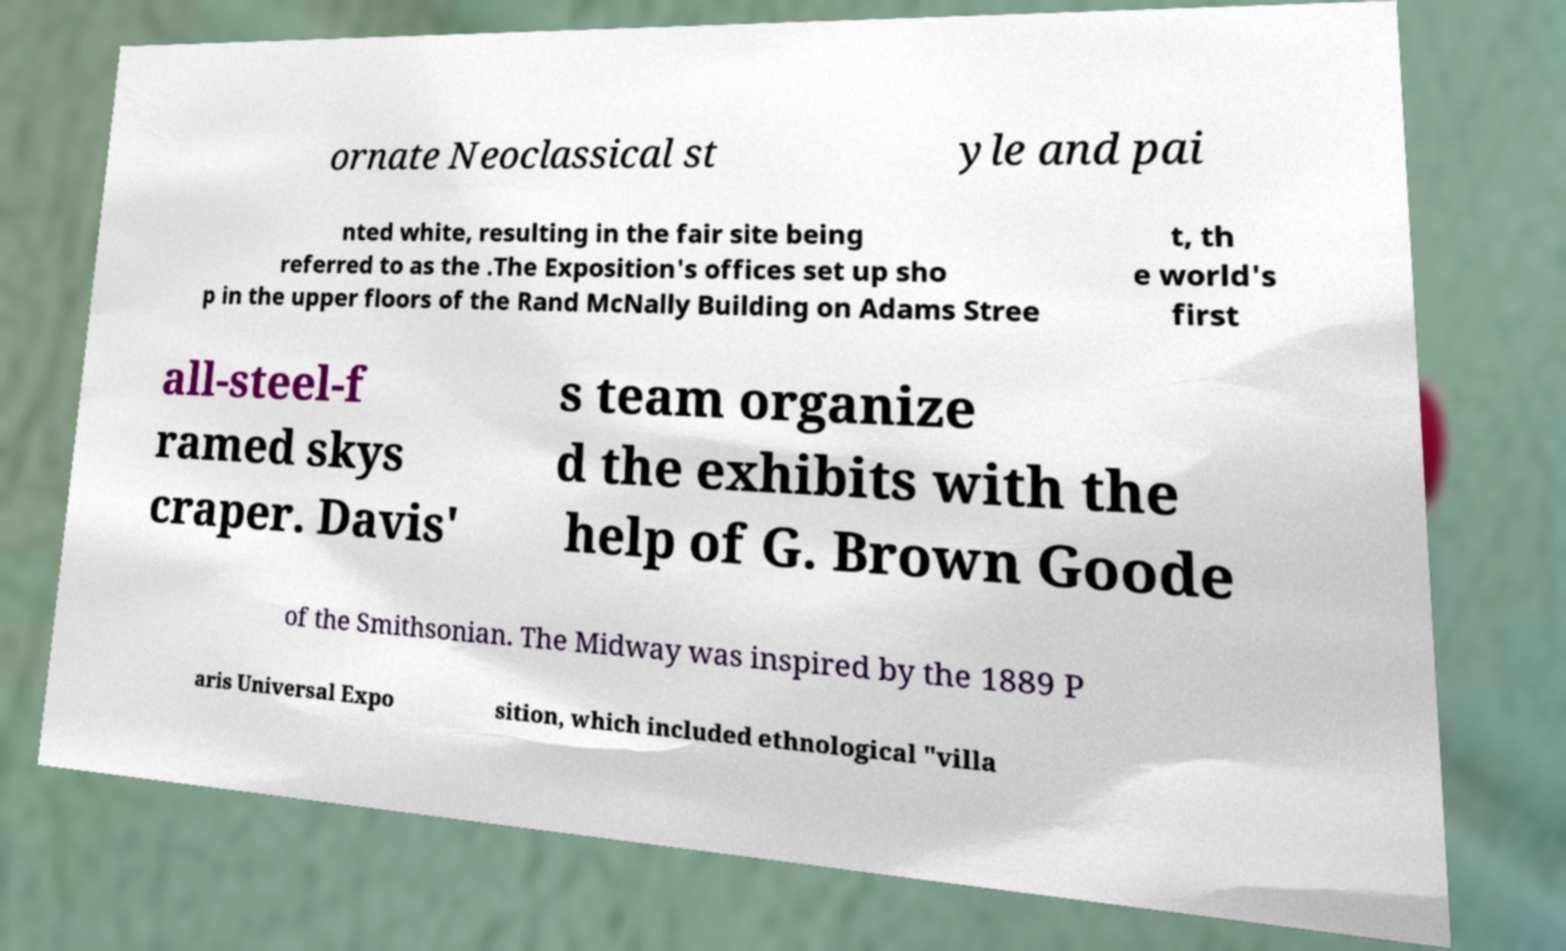Could you extract and type out the text from this image? ornate Neoclassical st yle and pai nted white, resulting in the fair site being referred to as the .The Exposition's offices set up sho p in the upper floors of the Rand McNally Building on Adams Stree t, th e world's first all-steel-f ramed skys craper. Davis' s team organize d the exhibits with the help of G. Brown Goode of the Smithsonian. The Midway was inspired by the 1889 P aris Universal Expo sition, which included ethnological "villa 